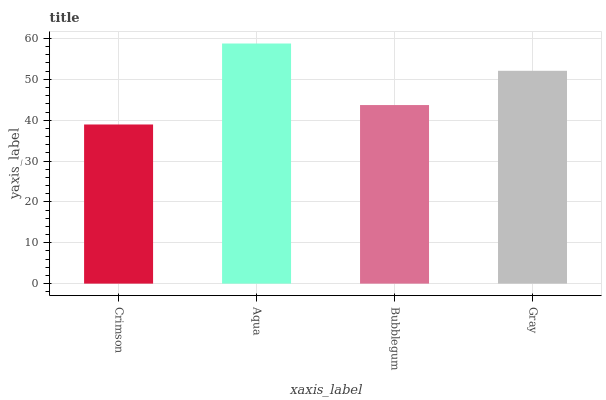Is Crimson the minimum?
Answer yes or no. Yes. Is Aqua the maximum?
Answer yes or no. Yes. Is Bubblegum the minimum?
Answer yes or no. No. Is Bubblegum the maximum?
Answer yes or no. No. Is Aqua greater than Bubblegum?
Answer yes or no. Yes. Is Bubblegum less than Aqua?
Answer yes or no. Yes. Is Bubblegum greater than Aqua?
Answer yes or no. No. Is Aqua less than Bubblegum?
Answer yes or no. No. Is Gray the high median?
Answer yes or no. Yes. Is Bubblegum the low median?
Answer yes or no. Yes. Is Crimson the high median?
Answer yes or no. No. Is Gray the low median?
Answer yes or no. No. 